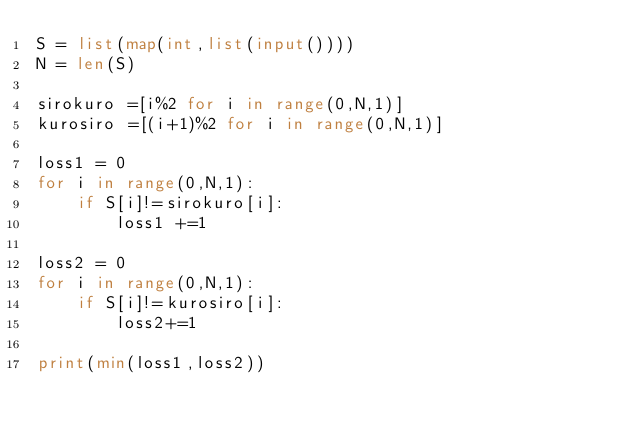Convert code to text. <code><loc_0><loc_0><loc_500><loc_500><_Python_>S = list(map(int,list(input())))
N = len(S)

sirokuro =[i%2 for i in range(0,N,1)]
kurosiro =[(i+1)%2 for i in range(0,N,1)]

loss1 = 0
for i in range(0,N,1):
    if S[i]!=sirokuro[i]:
        loss1 +=1

loss2 = 0
for i in range(0,N,1):
    if S[i]!=kurosiro[i]:
        loss2+=1

print(min(loss1,loss2))</code> 